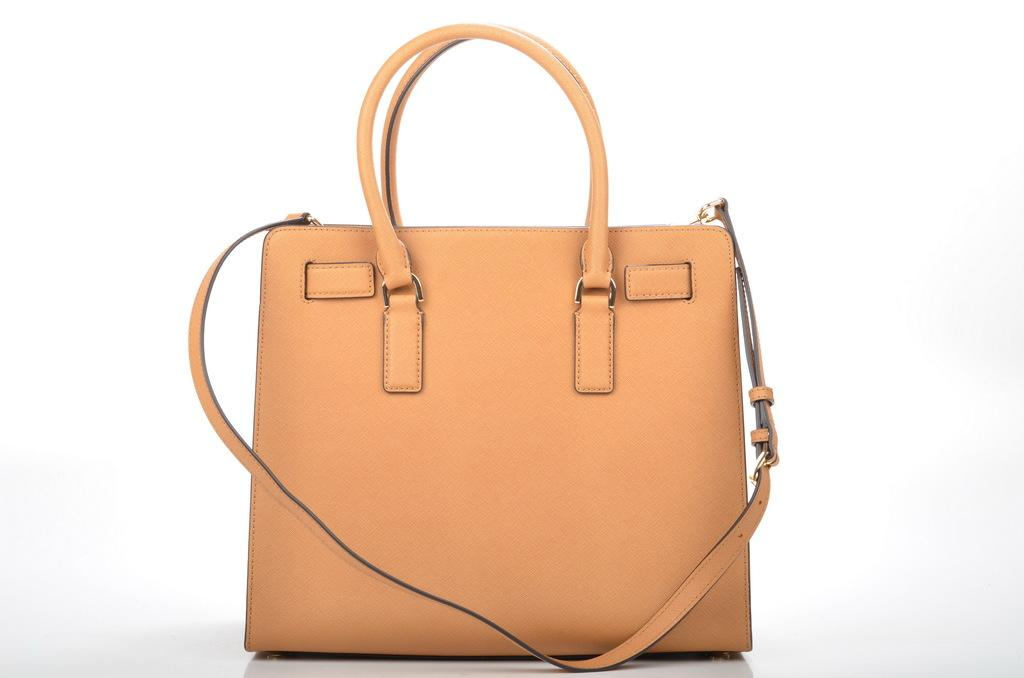What type of accessory is visible in the image? There is a handbag in the image. What type of punishment is being administered to the dog in the image? There is no dog present in the image, and therefore no punishment is being administered. Who is the expert in the image? There is no expert present in the image; it only features a handbag. 